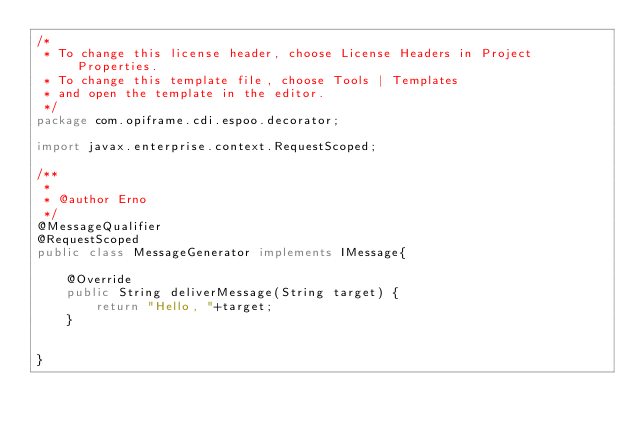Convert code to text. <code><loc_0><loc_0><loc_500><loc_500><_Java_>/*
 * To change this license header, choose License Headers in Project Properties.
 * To change this template file, choose Tools | Templates
 * and open the template in the editor.
 */
package com.opiframe.cdi.espoo.decorator;

import javax.enterprise.context.RequestScoped;

/**
 *
 * @author Erno
 */
@MessageQualifier
@RequestScoped
public class MessageGenerator implements IMessage{

    @Override
    public String deliverMessage(String target) {
        return "Hello, "+target;
    }
    
    
}
</code> 